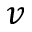Convert formula to latex. <formula><loc_0><loc_0><loc_500><loc_500>v</formula> 